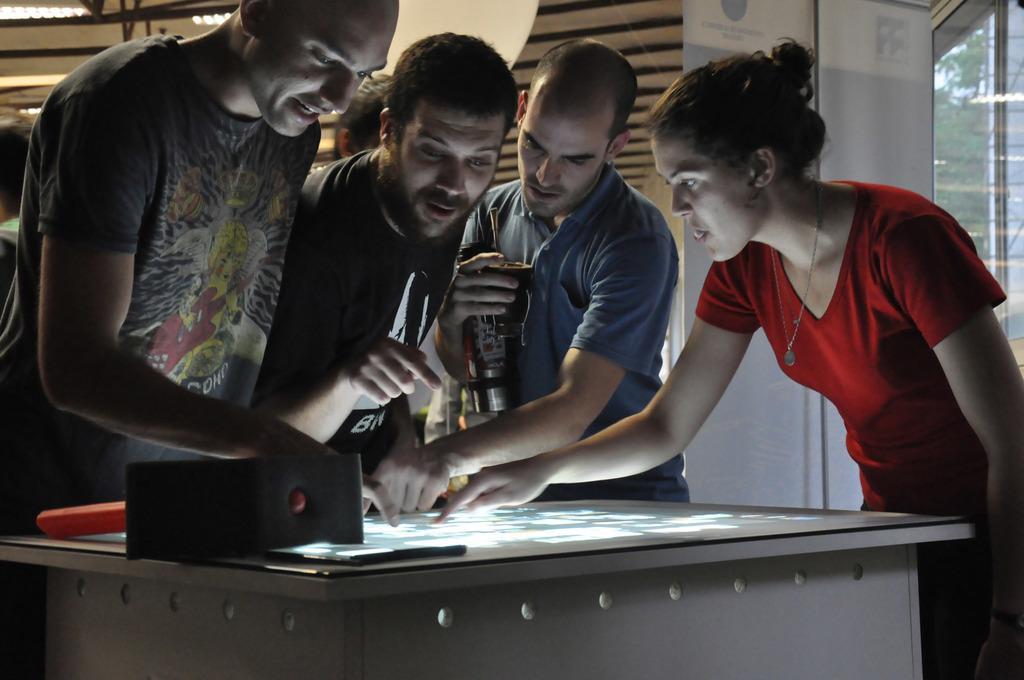In one or two sentences, can you explain what this image depicts? In this image I can see a group of people. 